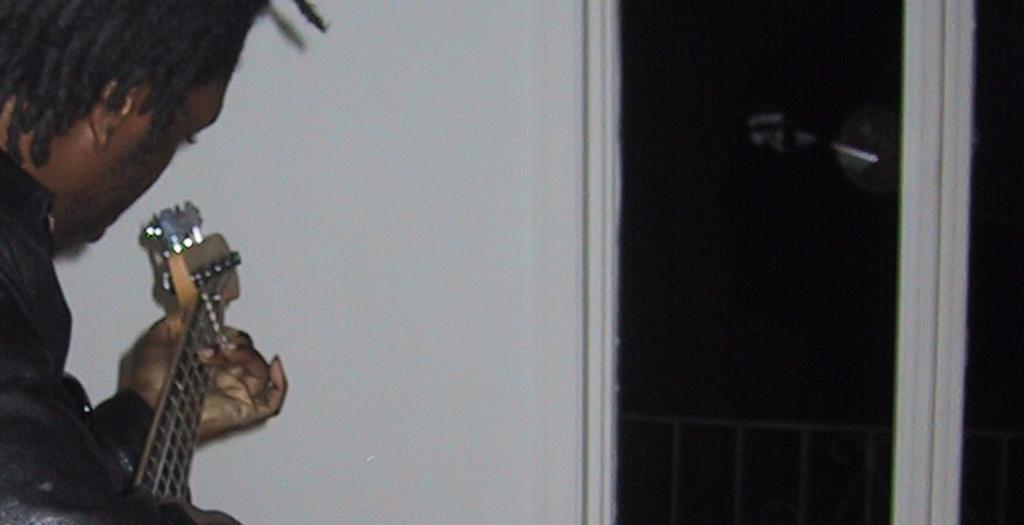Who is the main subject in the image? There is a man in the image. Where is the man located in the image? The man is on the left side of the image. What is the man holding in the image? The man is holding a guitar. What is the man doing with the guitar in the image? The man is playing the guitar. What type of glue is the man using to stick the suggestion on the wall in the image? There is no glue or suggestion present in the image; it features a man playing a guitar. 